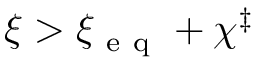<formula> <loc_0><loc_0><loc_500><loc_500>\xi > \xi _ { e q } + \chi ^ { \ddag }</formula> 